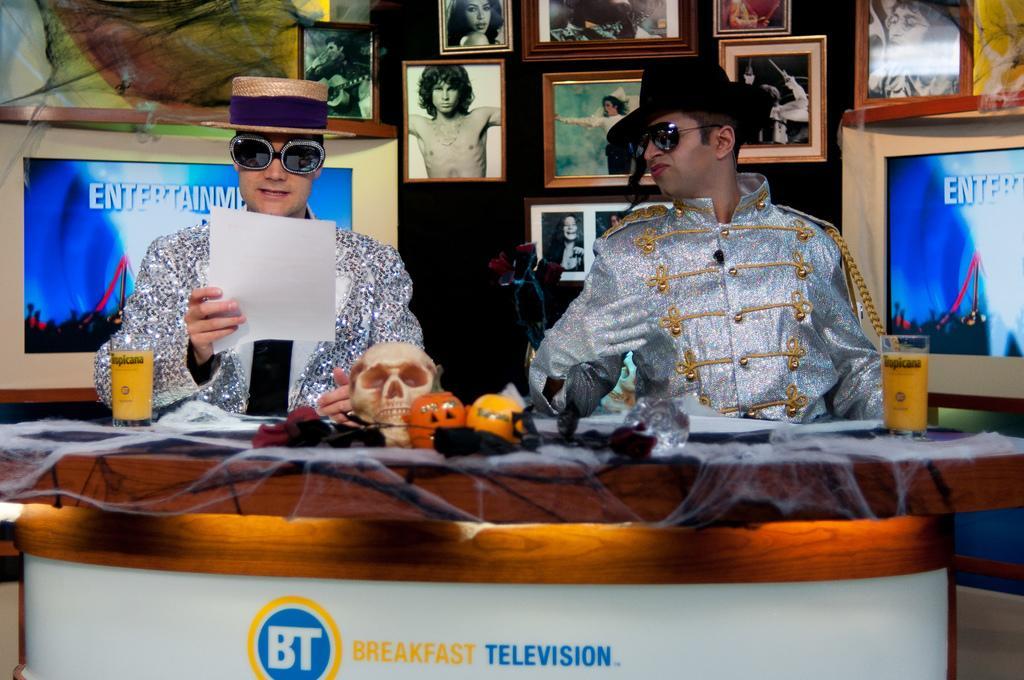Can you describe this image briefly? In this picture I can see two persons sitting, there is a person holding a paper, there is a skull and some other items, there are glasses with some liquids in it, on the table, and in the background there are frames attached to the wall. 